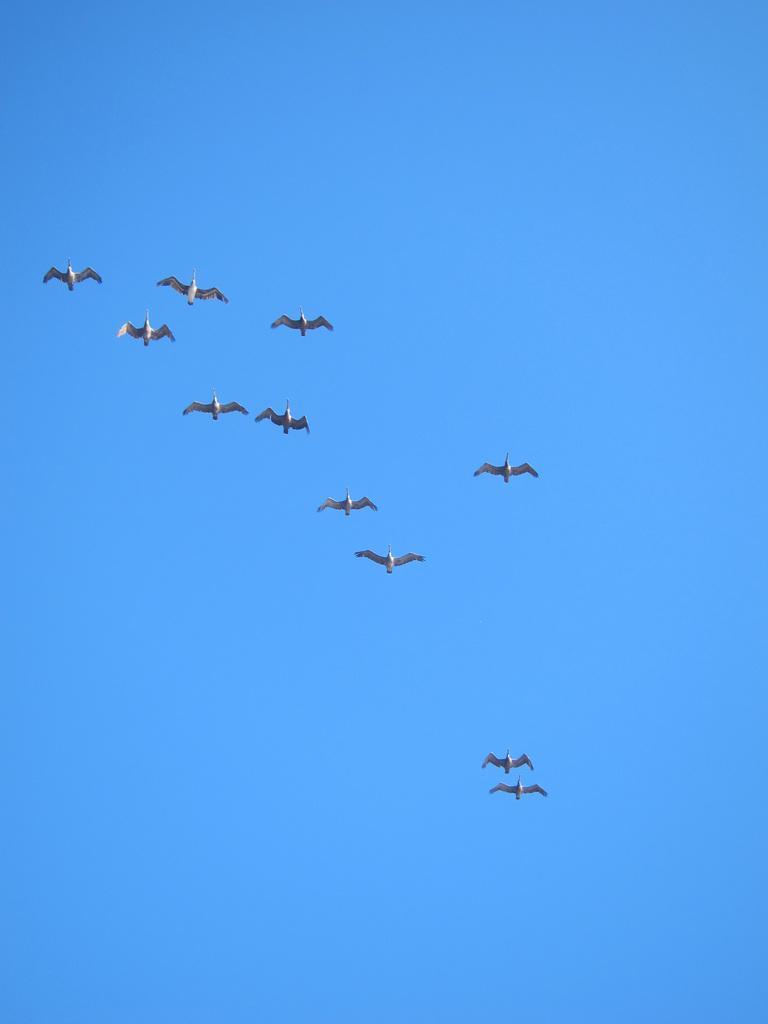How would you summarize this image in a sentence or two? In the image there are few birds flying in the sky. 